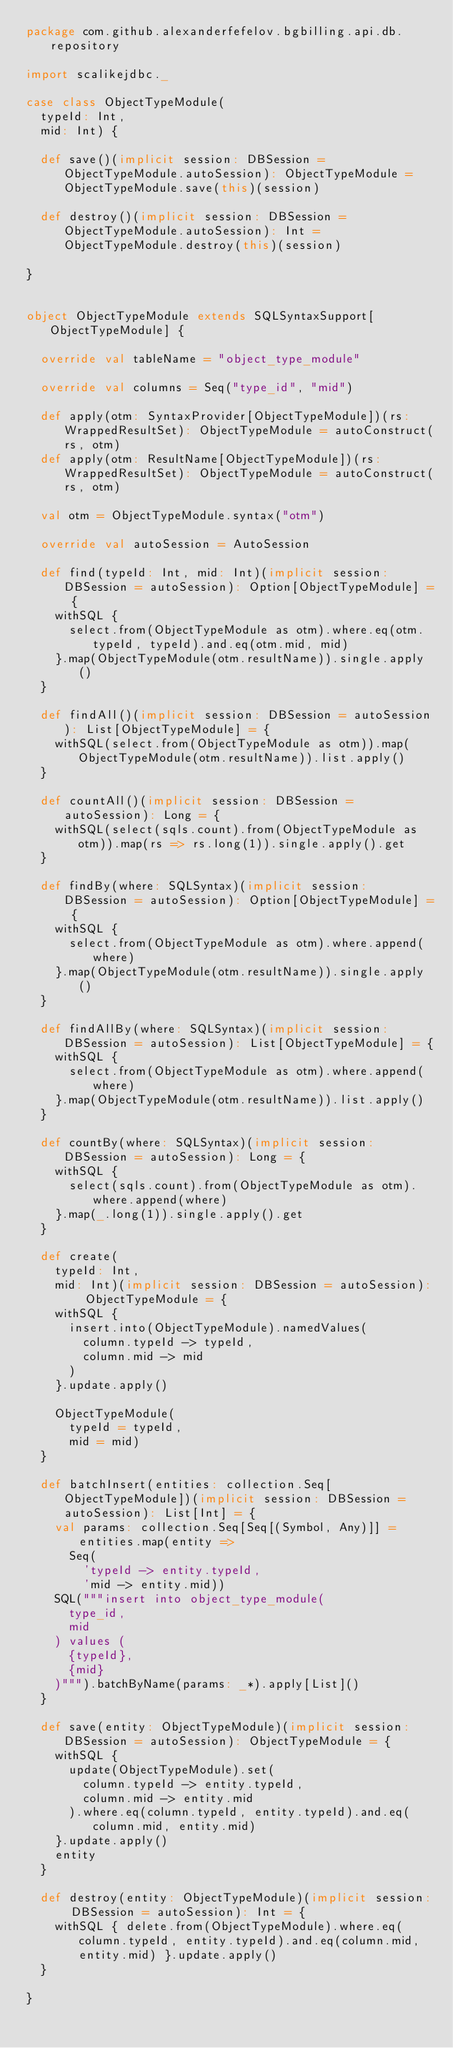<code> <loc_0><loc_0><loc_500><loc_500><_Scala_>package com.github.alexanderfefelov.bgbilling.api.db.repository

import scalikejdbc._

case class ObjectTypeModule(
  typeId: Int,
  mid: Int) {

  def save()(implicit session: DBSession = ObjectTypeModule.autoSession): ObjectTypeModule = ObjectTypeModule.save(this)(session)

  def destroy()(implicit session: DBSession = ObjectTypeModule.autoSession): Int = ObjectTypeModule.destroy(this)(session)

}


object ObjectTypeModule extends SQLSyntaxSupport[ObjectTypeModule] {

  override val tableName = "object_type_module"

  override val columns = Seq("type_id", "mid")

  def apply(otm: SyntaxProvider[ObjectTypeModule])(rs: WrappedResultSet): ObjectTypeModule = autoConstruct(rs, otm)
  def apply(otm: ResultName[ObjectTypeModule])(rs: WrappedResultSet): ObjectTypeModule = autoConstruct(rs, otm)

  val otm = ObjectTypeModule.syntax("otm")

  override val autoSession = AutoSession

  def find(typeId: Int, mid: Int)(implicit session: DBSession = autoSession): Option[ObjectTypeModule] = {
    withSQL {
      select.from(ObjectTypeModule as otm).where.eq(otm.typeId, typeId).and.eq(otm.mid, mid)
    }.map(ObjectTypeModule(otm.resultName)).single.apply()
  }

  def findAll()(implicit session: DBSession = autoSession): List[ObjectTypeModule] = {
    withSQL(select.from(ObjectTypeModule as otm)).map(ObjectTypeModule(otm.resultName)).list.apply()
  }

  def countAll()(implicit session: DBSession = autoSession): Long = {
    withSQL(select(sqls.count).from(ObjectTypeModule as otm)).map(rs => rs.long(1)).single.apply().get
  }

  def findBy(where: SQLSyntax)(implicit session: DBSession = autoSession): Option[ObjectTypeModule] = {
    withSQL {
      select.from(ObjectTypeModule as otm).where.append(where)
    }.map(ObjectTypeModule(otm.resultName)).single.apply()
  }

  def findAllBy(where: SQLSyntax)(implicit session: DBSession = autoSession): List[ObjectTypeModule] = {
    withSQL {
      select.from(ObjectTypeModule as otm).where.append(where)
    }.map(ObjectTypeModule(otm.resultName)).list.apply()
  }

  def countBy(where: SQLSyntax)(implicit session: DBSession = autoSession): Long = {
    withSQL {
      select(sqls.count).from(ObjectTypeModule as otm).where.append(where)
    }.map(_.long(1)).single.apply().get
  }

  def create(
    typeId: Int,
    mid: Int)(implicit session: DBSession = autoSession): ObjectTypeModule = {
    withSQL {
      insert.into(ObjectTypeModule).namedValues(
        column.typeId -> typeId,
        column.mid -> mid
      )
    }.update.apply()

    ObjectTypeModule(
      typeId = typeId,
      mid = mid)
  }

  def batchInsert(entities: collection.Seq[ObjectTypeModule])(implicit session: DBSession = autoSession): List[Int] = {
    val params: collection.Seq[Seq[(Symbol, Any)]] = entities.map(entity =>
      Seq(
        'typeId -> entity.typeId,
        'mid -> entity.mid))
    SQL("""insert into object_type_module(
      type_id,
      mid
    ) values (
      {typeId},
      {mid}
    )""").batchByName(params: _*).apply[List]()
  }

  def save(entity: ObjectTypeModule)(implicit session: DBSession = autoSession): ObjectTypeModule = {
    withSQL {
      update(ObjectTypeModule).set(
        column.typeId -> entity.typeId,
        column.mid -> entity.mid
      ).where.eq(column.typeId, entity.typeId).and.eq(column.mid, entity.mid)
    }.update.apply()
    entity
  }

  def destroy(entity: ObjectTypeModule)(implicit session: DBSession = autoSession): Int = {
    withSQL { delete.from(ObjectTypeModule).where.eq(column.typeId, entity.typeId).and.eq(column.mid, entity.mid) }.update.apply()
  }

}
</code> 